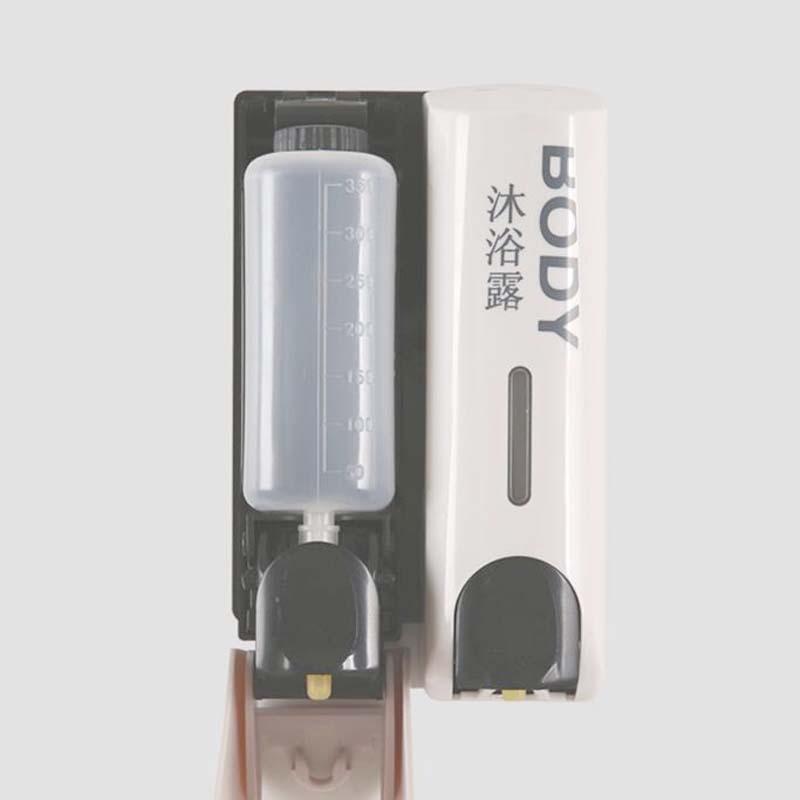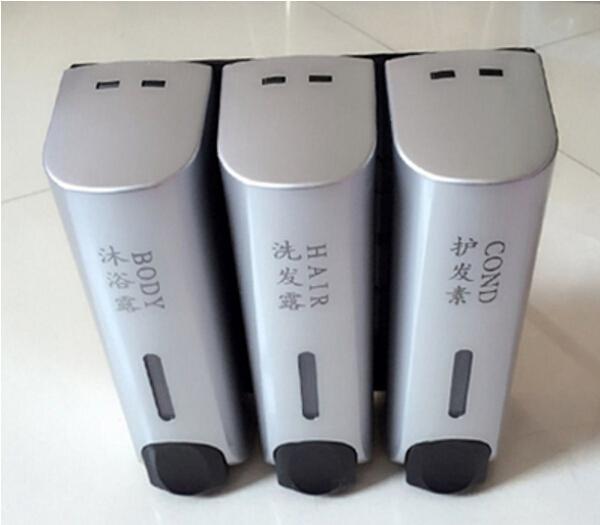The first image is the image on the left, the second image is the image on the right. Assess this claim about the two images: "There are two cleaning products on the left and three on the right.". Correct or not? Answer yes or no. Yes. The first image is the image on the left, the second image is the image on the right. Given the left and right images, does the statement "An image shows three side-by-side gold dispensers with black push buttons." hold true? Answer yes or no. No. 